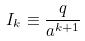Convert formula to latex. <formula><loc_0><loc_0><loc_500><loc_500>I _ { k } \equiv \frac { q } { a ^ { k + 1 } }</formula> 